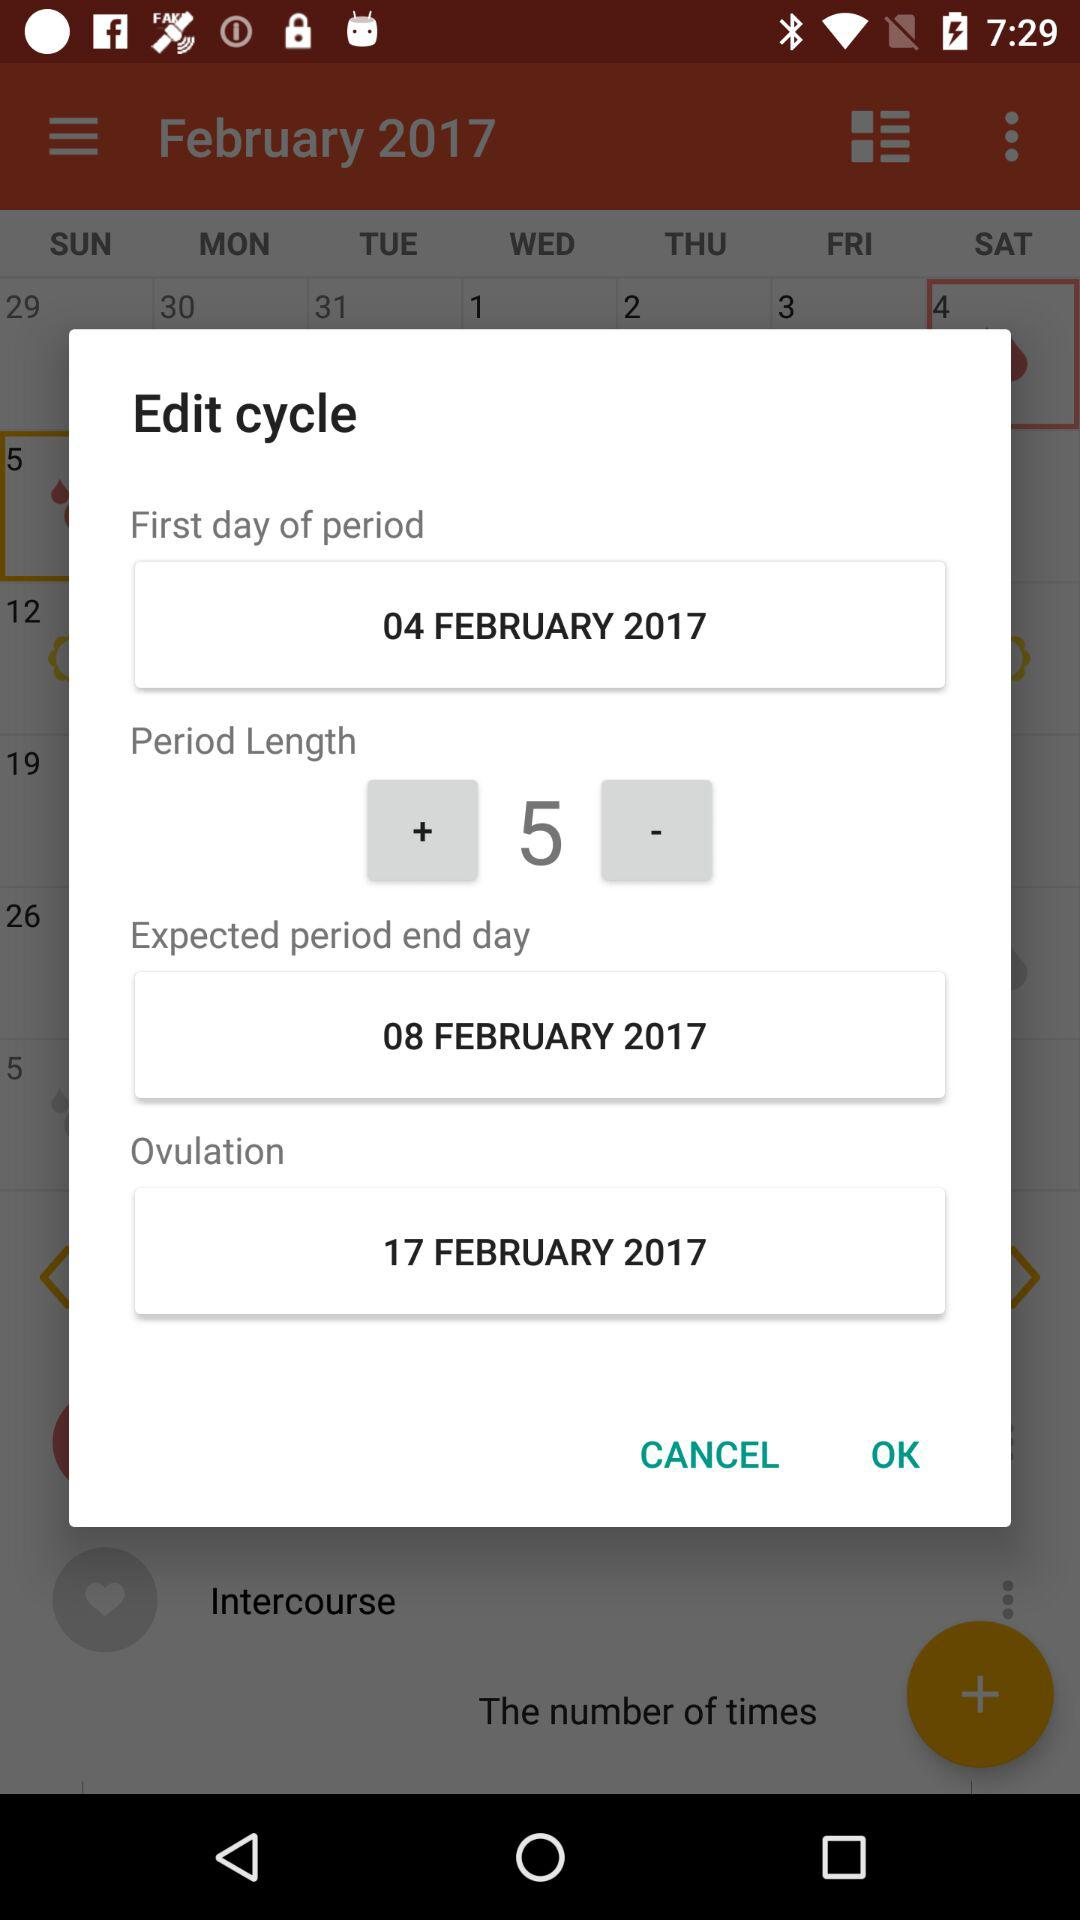What is the expected length of the user's cycle?
Answer the question using a single word or phrase. 5 days 